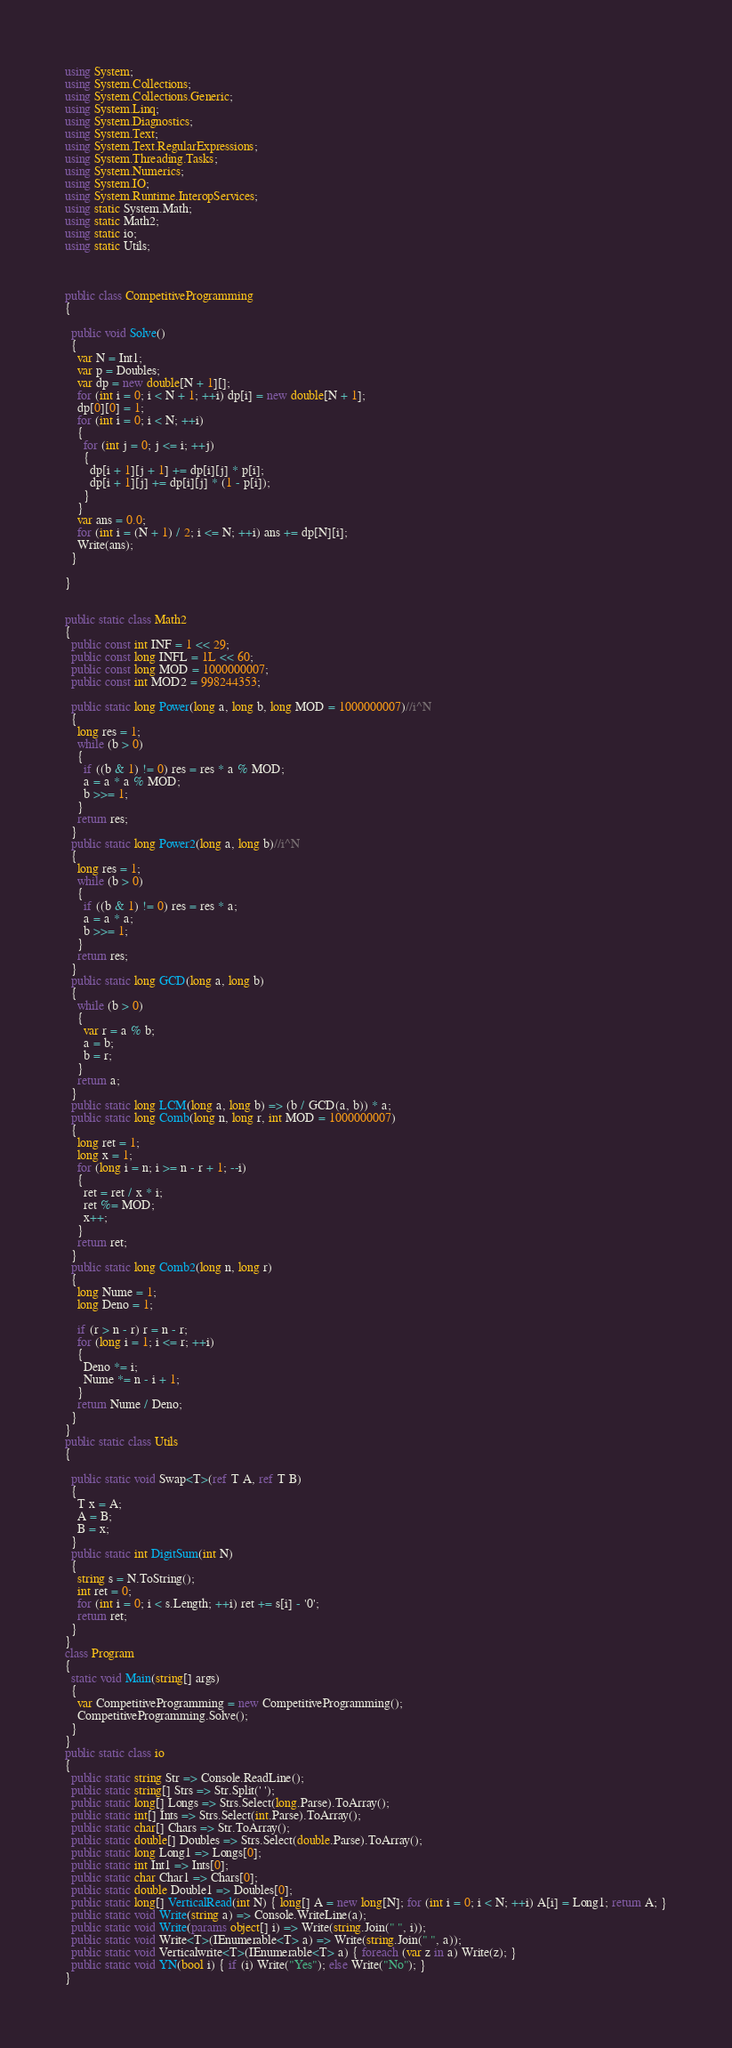<code> <loc_0><loc_0><loc_500><loc_500><_C#_>using System;
using System.Collections;
using System.Collections.Generic;
using System.Linq;
using System.Diagnostics;
using System.Text;
using System.Text.RegularExpressions;
using System.Threading.Tasks;
using System.Numerics;
using System.IO;
using System.Runtime.InteropServices;
using static System.Math;
using static Math2;
using static io;
using static Utils;



public class CompetitiveProgramming
{

  public void Solve()
  {
    var N = Int1;
    var p = Doubles;
    var dp = new double[N + 1][];
    for (int i = 0; i < N + 1; ++i) dp[i] = new double[N + 1];
    dp[0][0] = 1;
    for (int i = 0; i < N; ++i)
    {
      for (int j = 0; j <= i; ++j)
      {
        dp[i + 1][j + 1] += dp[i][j] * p[i];
        dp[i + 1][j] += dp[i][j] * (1 - p[i]);
      }
    }
    var ans = 0.0;
    for (int i = (N + 1) / 2; i <= N; ++i) ans += dp[N][i];
    Write(ans);
  }

}


public static class Math2
{
  public const int INF = 1 << 29;
  public const long INFL = 1L << 60;
  public const long MOD = 1000000007;
  public const int MOD2 = 998244353;

  public static long Power(long a, long b, long MOD = 1000000007)//i^N
  {
    long res = 1;
    while (b > 0)
    {
      if ((b & 1) != 0) res = res * a % MOD;
      a = a * a % MOD;
      b >>= 1;
    }
    return res;
  }
  public static long Power2(long a, long b)//i^N
  {
    long res = 1;
    while (b > 0)
    {
      if ((b & 1) != 0) res = res * a;
      a = a * a;
      b >>= 1;
    }
    return res;
  }
  public static long GCD(long a, long b)
  {
    while (b > 0)
    {
      var r = a % b;
      a = b;
      b = r;
    }
    return a;
  }
  public static long LCM(long a, long b) => (b / GCD(a, b)) * a;
  public static long Comb(long n, long r, int MOD = 1000000007)
  {
    long ret = 1;
    long x = 1;
    for (long i = n; i >= n - r + 1; --i)
    {
      ret = ret / x * i;
      ret %= MOD;
      x++;
    }
    return ret;
  }
  public static long Comb2(long n, long r)
  {
    long Nume = 1;
    long Deno = 1;

    if (r > n - r) r = n - r;
    for (long i = 1; i <= r; ++i)
    {
      Deno *= i;
      Nume *= n - i + 1;
    }
    return Nume / Deno;
  }
}
public static class Utils
{

  public static void Swap<T>(ref T A, ref T B)
  {
    T x = A;
    A = B;
    B = x;
  }
  public static int DigitSum(int N)
  {
    string s = N.ToString();
    int ret = 0;
    for (int i = 0; i < s.Length; ++i) ret += s[i] - '0';
    return ret;
  }
}
class Program
{
  static void Main(string[] args)
  {
    var CompetitiveProgramming = new CompetitiveProgramming();
    CompetitiveProgramming.Solve();
  }
}
public static class io
{
  public static string Str => Console.ReadLine();
  public static string[] Strs => Str.Split(' ');
  public static long[] Longs => Strs.Select(long.Parse).ToArray();
  public static int[] Ints => Strs.Select(int.Parse).ToArray();
  public static char[] Chars => Str.ToArray();
  public static double[] Doubles => Strs.Select(double.Parse).ToArray();
  public static long Long1 => Longs[0];
  public static int Int1 => Ints[0];
  public static char Char1 => Chars[0];
  public static double Double1 => Doubles[0];
  public static long[] VerticalRead(int N) { long[] A = new long[N]; for (int i = 0; i < N; ++i) A[i] = Long1; return A; }
  public static void Write(string a) => Console.WriteLine(a);
  public static void Write(params object[] i) => Write(string.Join(" ", i));
  public static void Write<T>(IEnumerable<T> a) => Write(string.Join(" ", a));
  public static void Verticalwrite<T>(IEnumerable<T> a) { foreach (var z in a) Write(z); }
  public static void YN(bool i) { if (i) Write("Yes"); else Write("No"); }
}</code> 